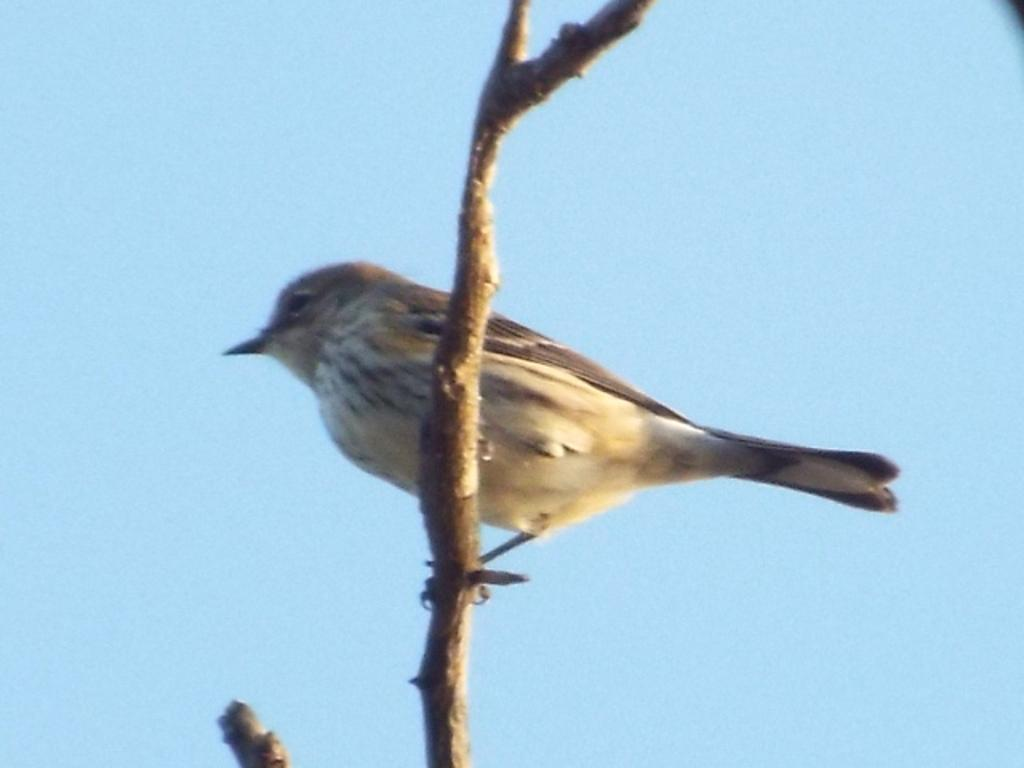What object can be seen in the image that is made of wood? There is a wooden stick in the image. What is on the wooden stick? A bird is perched on the wooden stick. Can you describe the bird's appearance? The bird has white, black, and brown colors. What is the color of the sky in the image? The sky in the image is blue. Where is the carpenter working in the image? There is no carpenter present in the image. What type of hen can be seen in the image? There is no hen present in the image. 